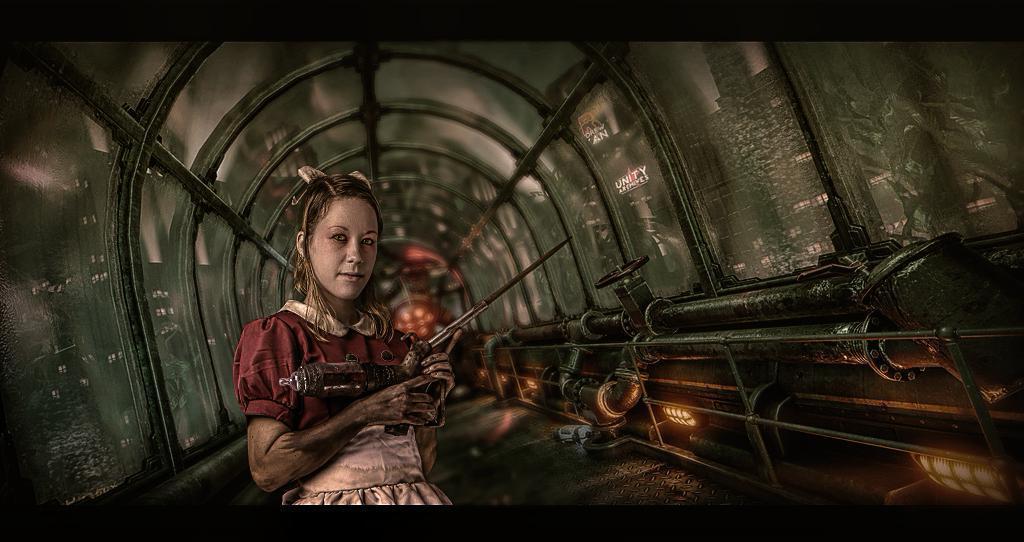Please provide a concise description of this image. In this image I can see a woman wearing red and pink dress is standing and holding an object in her hand. In the background I can see few pipes, few lights and a tunnel and through the glass of the tunnel I can see few buildings and a tree. 